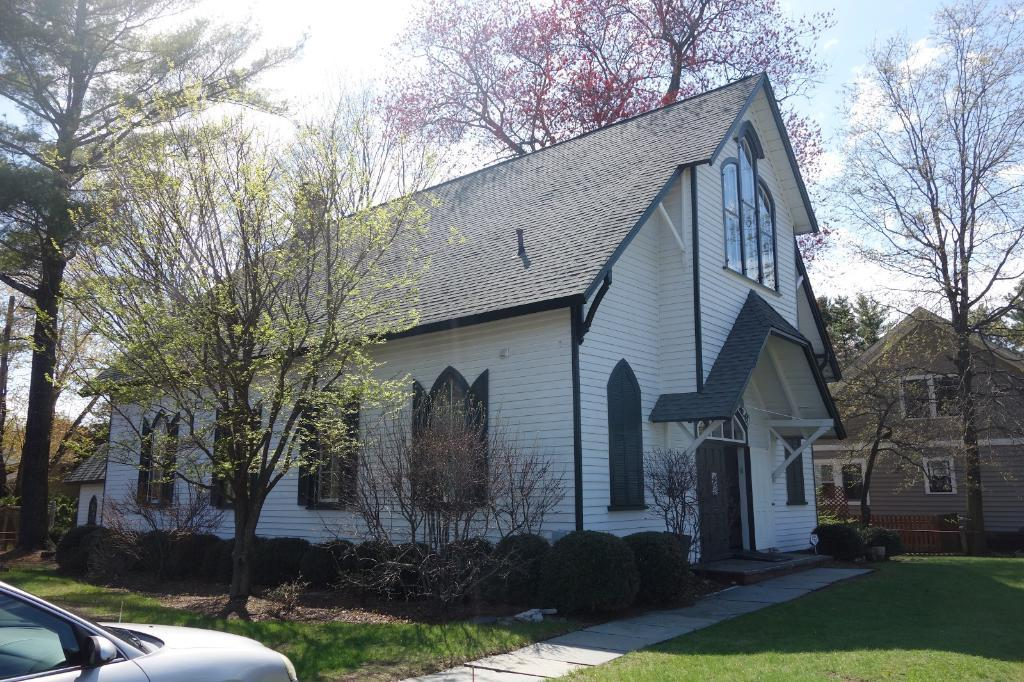What structures are located in the center of the image? There are two houses in the center of the image. What type of vegetation is present in the image? There are trees and plants in the image. What is the path made of at the bottom of the image? There is a grass walkway at the bottom of the image. What vehicle can be seen on the grass walkway? There is a car on the grass walkway. What is visible at the top of the image? The sky is visible at the top of the image. How many balls are hanging from the string in the image? There are no balls or string present in the image. What type of mine is visible in the image? There is no mine present in the image. 